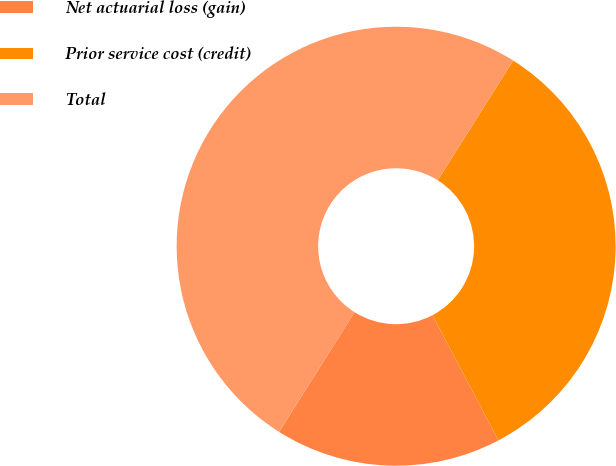Convert chart to OTSL. <chart><loc_0><loc_0><loc_500><loc_500><pie_chart><fcel>Net actuarial loss (gain)<fcel>Prior service cost (credit)<fcel>Total<nl><fcel>16.67%<fcel>33.33%<fcel>50.0%<nl></chart> 